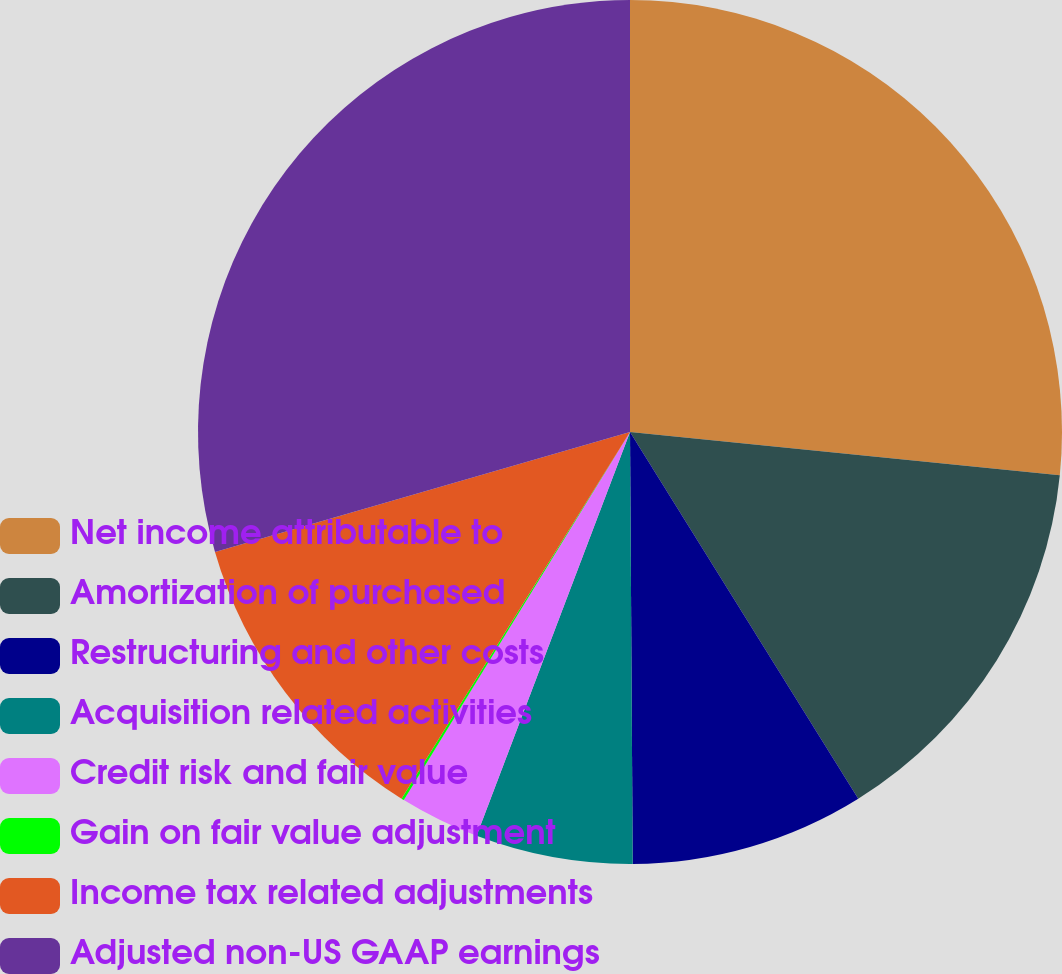Convert chart to OTSL. <chart><loc_0><loc_0><loc_500><loc_500><pie_chart><fcel>Net income attributable to<fcel>Amortization of purchased<fcel>Restructuring and other costs<fcel>Acquisition related activities<fcel>Credit risk and fair value<fcel>Gain on fair value adjustment<fcel>Income tax related adjustments<fcel>Adjusted non-US GAAP earnings<nl><fcel>26.6%<fcel>14.54%<fcel>8.76%<fcel>5.88%<fcel>2.99%<fcel>0.1%<fcel>11.65%<fcel>29.48%<nl></chart> 